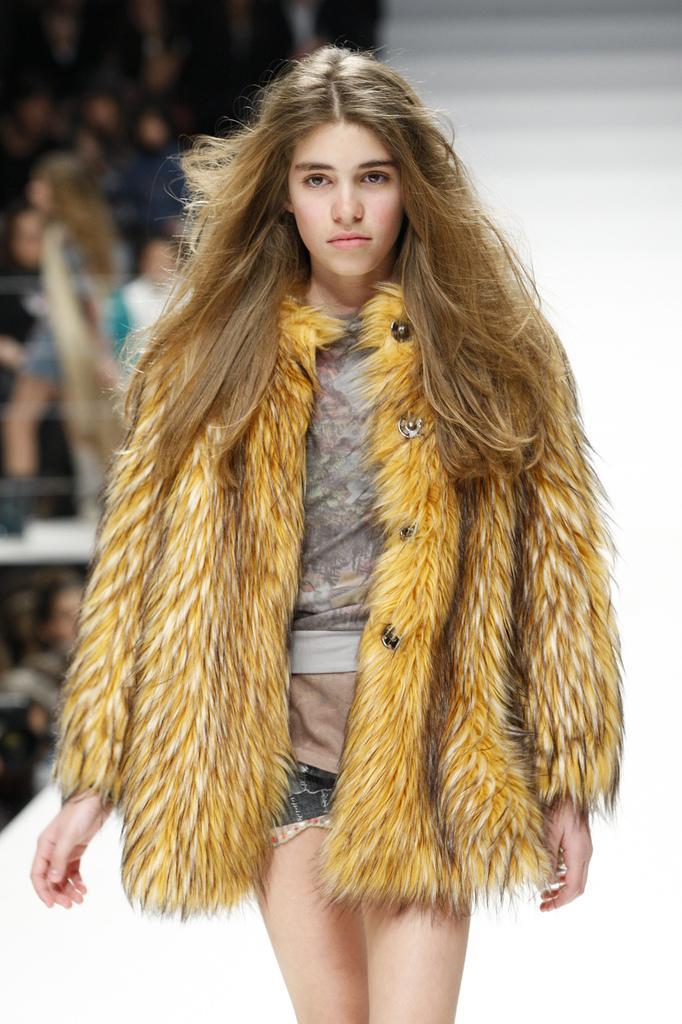Describe this image in one or two sentences. In this image we can see a lady wearing fur jacket. In the background there are people and it is blurry. 